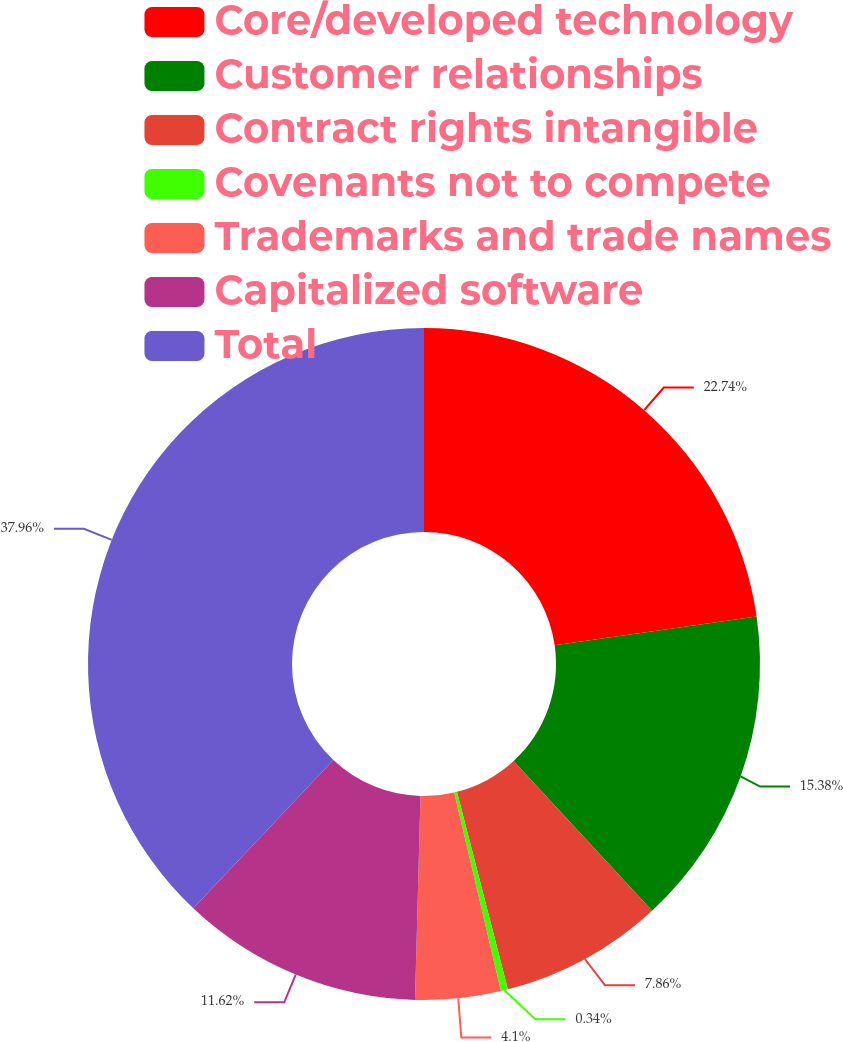<chart> <loc_0><loc_0><loc_500><loc_500><pie_chart><fcel>Core/developed technology<fcel>Customer relationships<fcel>Contract rights intangible<fcel>Covenants not to compete<fcel>Trademarks and trade names<fcel>Capitalized software<fcel>Total<nl><fcel>22.74%<fcel>15.38%<fcel>7.86%<fcel>0.34%<fcel>4.1%<fcel>11.62%<fcel>37.95%<nl></chart> 